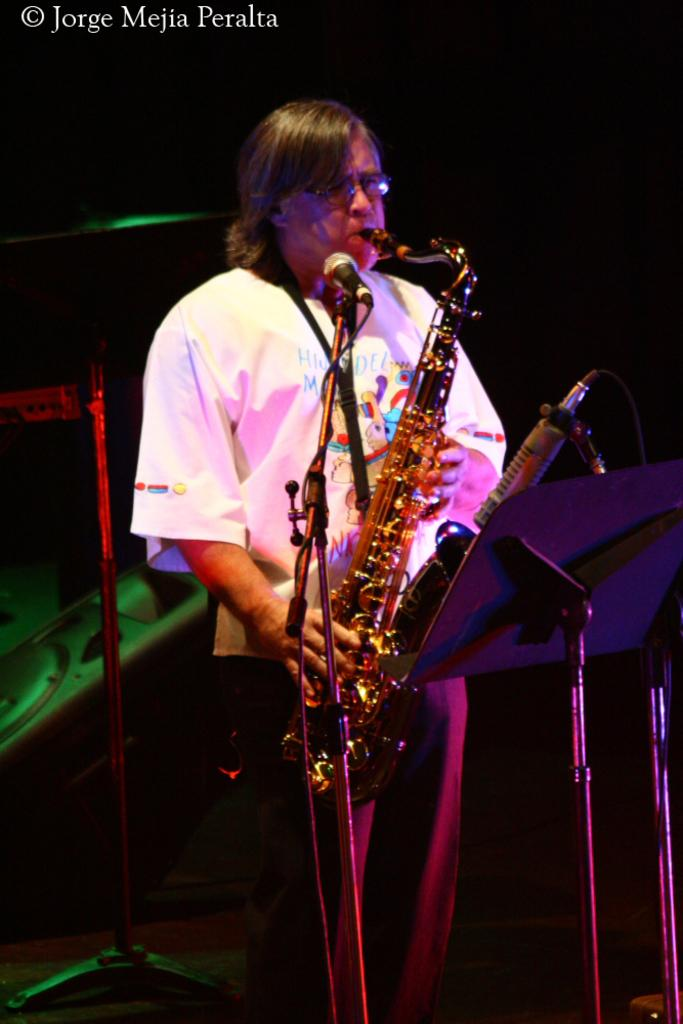What is the person in the image doing? The person in the image is playing a musical instrument. What is placed in front of the person? There are microphones (mics) in front of the person. What is the purpose of the stand in front of the person? The stand in front of the person is likely for holding sheet music or lyrics. What color is the background of the image? The background of the image is black. What type of book is the actor holding while standing on the beam in the image? There is no actor, book, or beam present in the image. The image features a person playing a musical instrument with microphones and a stand in front of them, and the background is black. 